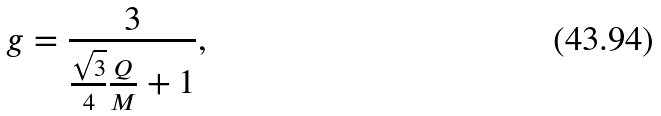Convert formula to latex. <formula><loc_0><loc_0><loc_500><loc_500>g = \frac { 3 } { \frac { \sqrt { 3 } } { 4 } \frac { Q } { M } + 1 } ,</formula> 